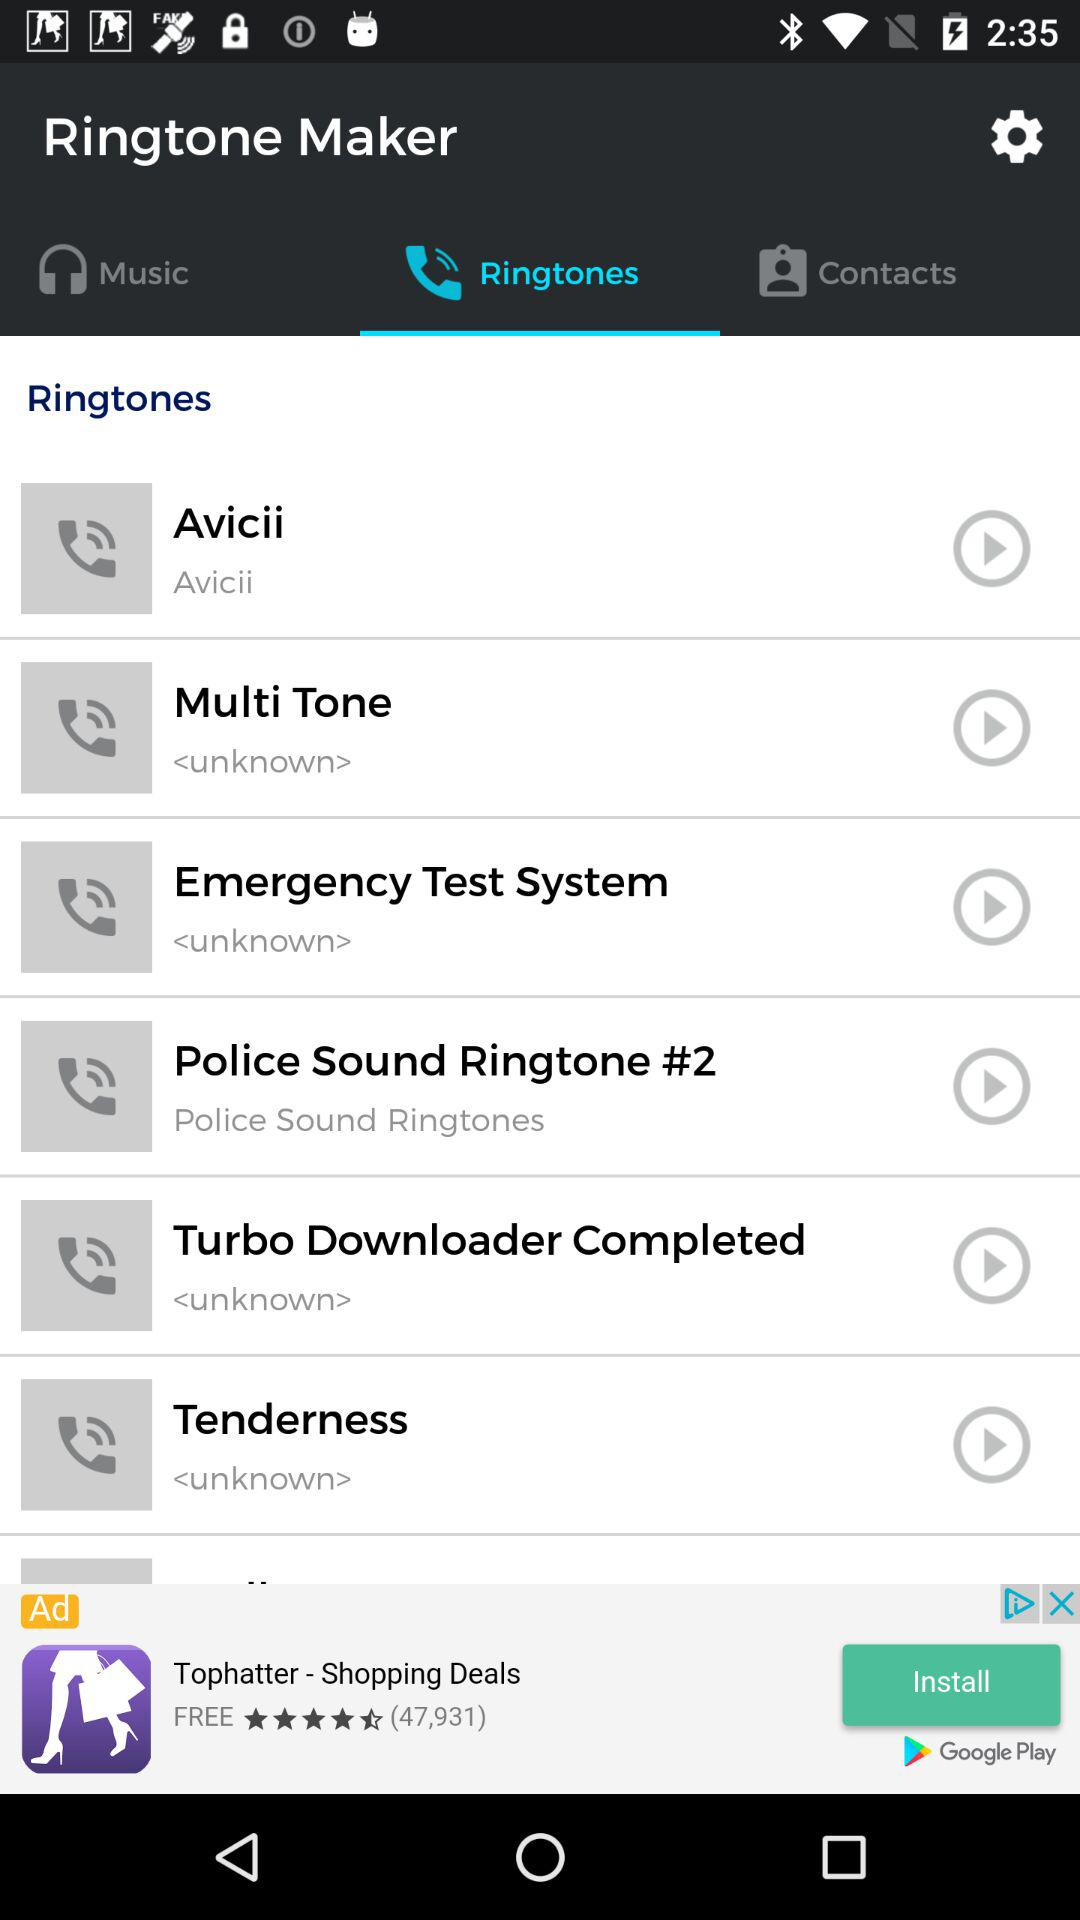Which tab has been selected? The selected tab is "Ringtones". 